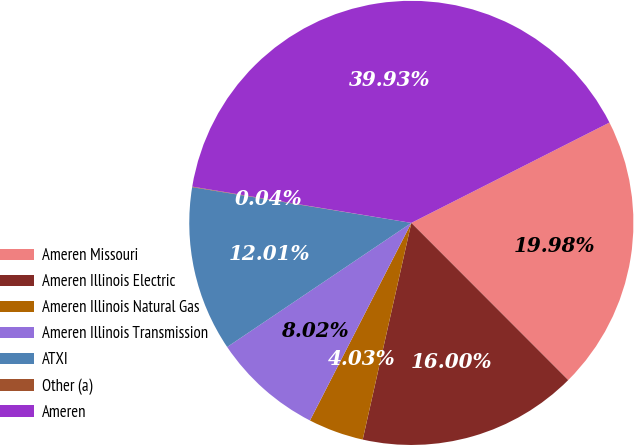Convert chart to OTSL. <chart><loc_0><loc_0><loc_500><loc_500><pie_chart><fcel>Ameren Missouri<fcel>Ameren Illinois Electric<fcel>Ameren Illinois Natural Gas<fcel>Ameren Illinois Transmission<fcel>ATXI<fcel>Other (a)<fcel>Ameren<nl><fcel>19.98%<fcel>16.0%<fcel>4.03%<fcel>8.02%<fcel>12.01%<fcel>0.04%<fcel>39.93%<nl></chart> 